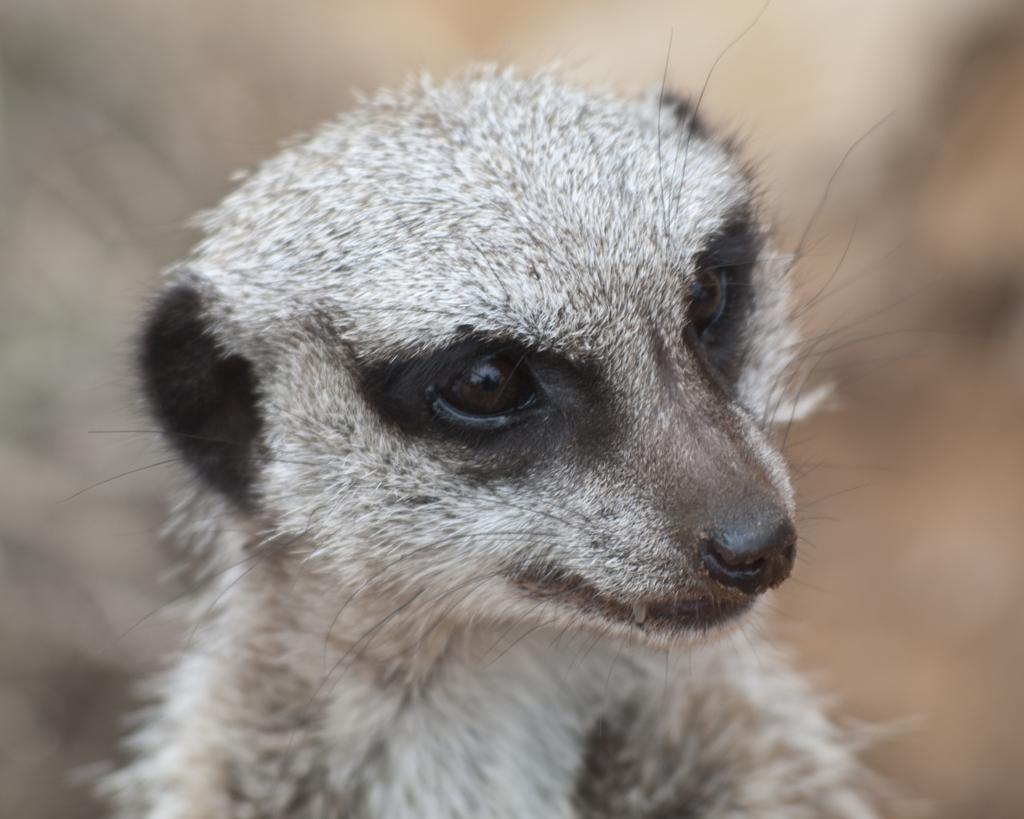What type of creature is present in the image? There is an animal in the image. In which direction is the animal looking? The animal is looking to the right. What color are the animal's eyes, nose, and ears? The animal's eyes, nose, and ears are black. How would you describe the background of the image? The background of the image is blurred. What does the writer think about the existence of the branch in the image? There is no writer or branch present in the image, so it is not possible to answer that question. 